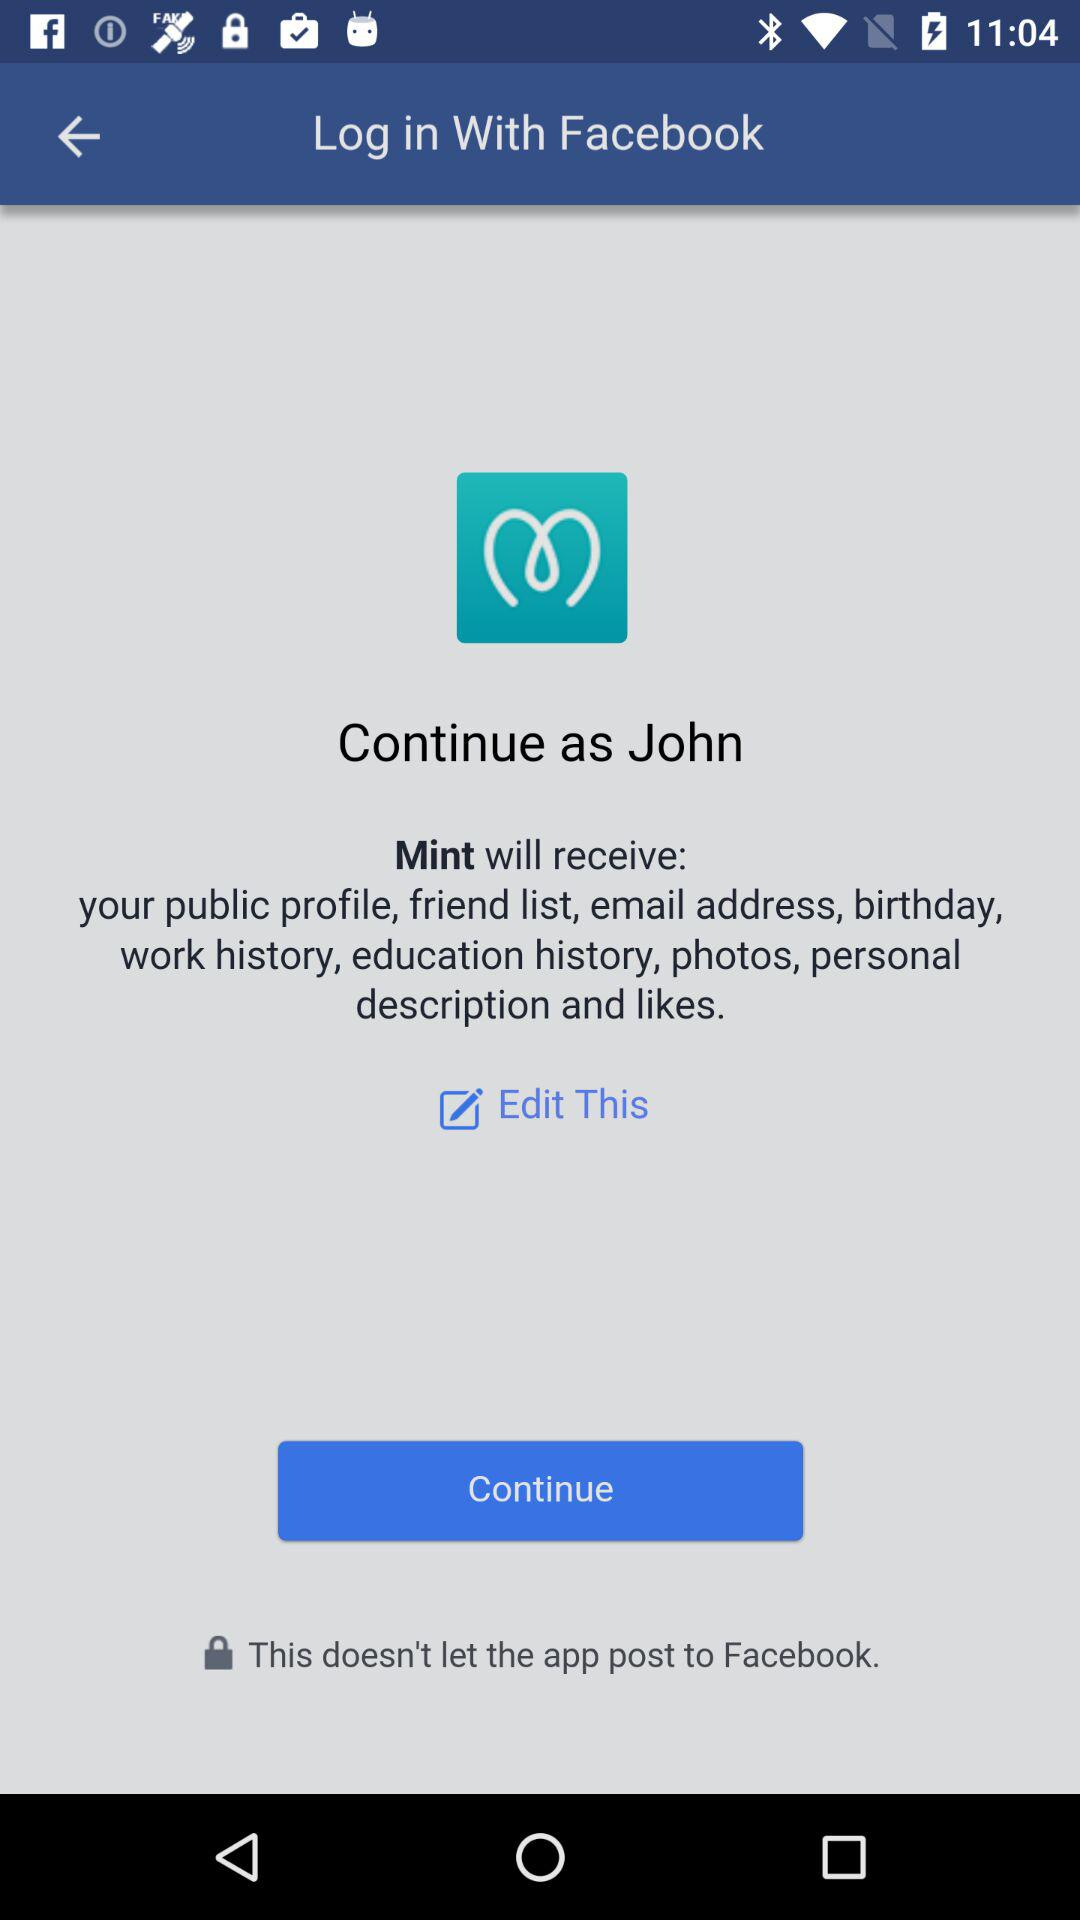What application is asking for permission? The application is "Mint". 